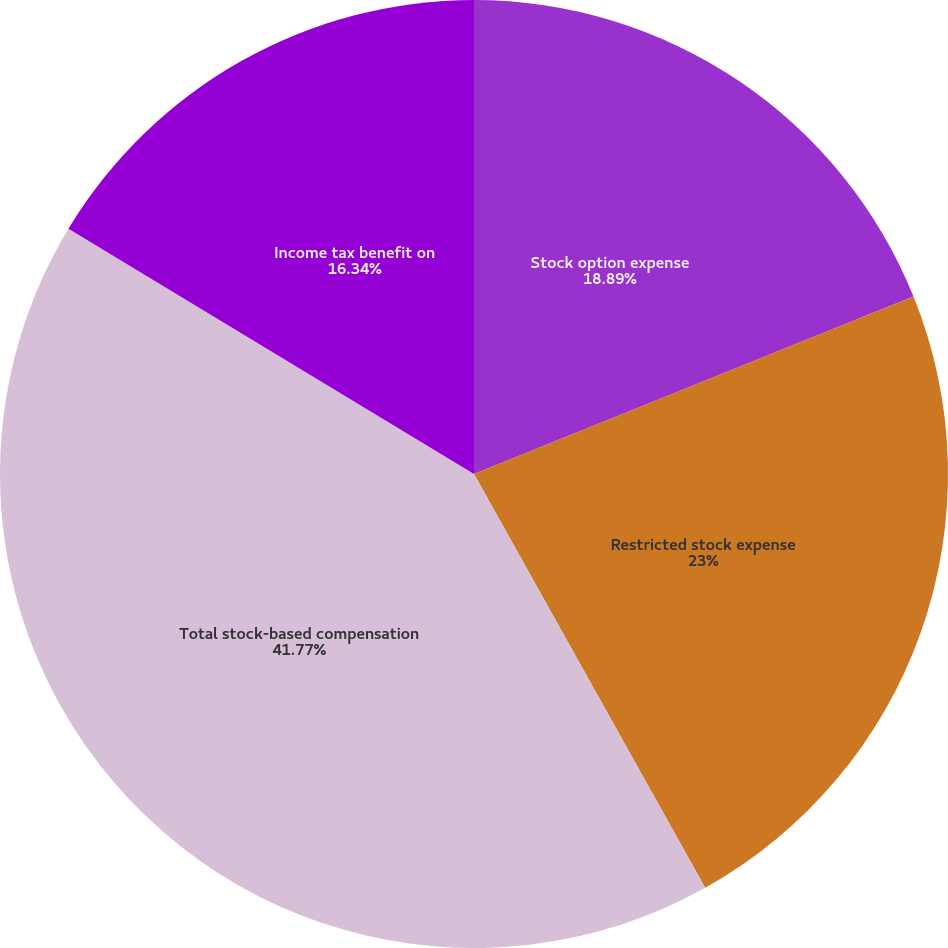Convert chart to OTSL. <chart><loc_0><loc_0><loc_500><loc_500><pie_chart><fcel>Stock option expense<fcel>Restricted stock expense<fcel>Total stock-based compensation<fcel>Income tax benefit on<nl><fcel>18.89%<fcel>23.0%<fcel>41.77%<fcel>16.34%<nl></chart> 